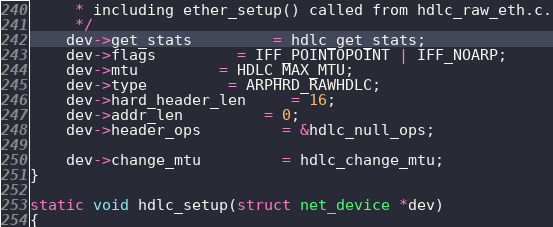<code> <loc_0><loc_0><loc_500><loc_500><_C_>	 * including ether_setup() called from hdlc_raw_eth.c.
	 */
	dev->get_stats		 = hdlc_get_stats;
	dev->flags		 = IFF_POINTOPOINT | IFF_NOARP;
	dev->mtu		 = HDLC_MAX_MTU;
	dev->type		 = ARPHRD_RAWHDLC;
	dev->hard_header_len	 = 16;
	dev->addr_len		 = 0;
	dev->header_ops		 = &hdlc_null_ops;

	dev->change_mtu		 = hdlc_change_mtu;
}

static void hdlc_setup(struct net_device *dev)
{</code> 